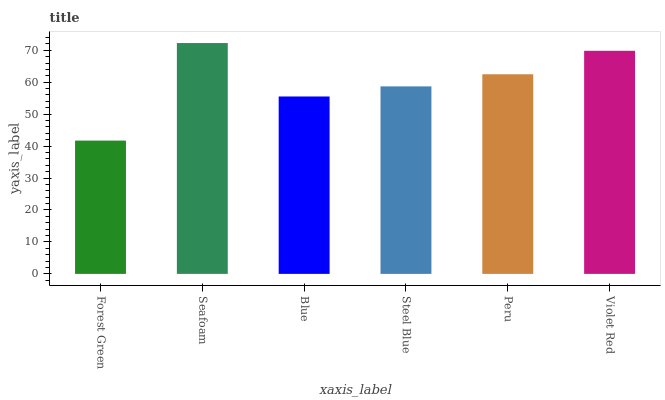Is Blue the minimum?
Answer yes or no. No. Is Blue the maximum?
Answer yes or no. No. Is Seafoam greater than Blue?
Answer yes or no. Yes. Is Blue less than Seafoam?
Answer yes or no. Yes. Is Blue greater than Seafoam?
Answer yes or no. No. Is Seafoam less than Blue?
Answer yes or no. No. Is Peru the high median?
Answer yes or no. Yes. Is Steel Blue the low median?
Answer yes or no. Yes. Is Blue the high median?
Answer yes or no. No. Is Peru the low median?
Answer yes or no. No. 